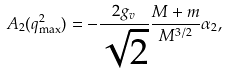<formula> <loc_0><loc_0><loc_500><loc_500>A _ { 2 } ( q _ { \max } ^ { 2 } ) = - \frac { 2 g _ { v } } { \sqrt { 2 } } \frac { M + m } { M ^ { 3 / 2 } } \alpha _ { 2 } ,</formula> 